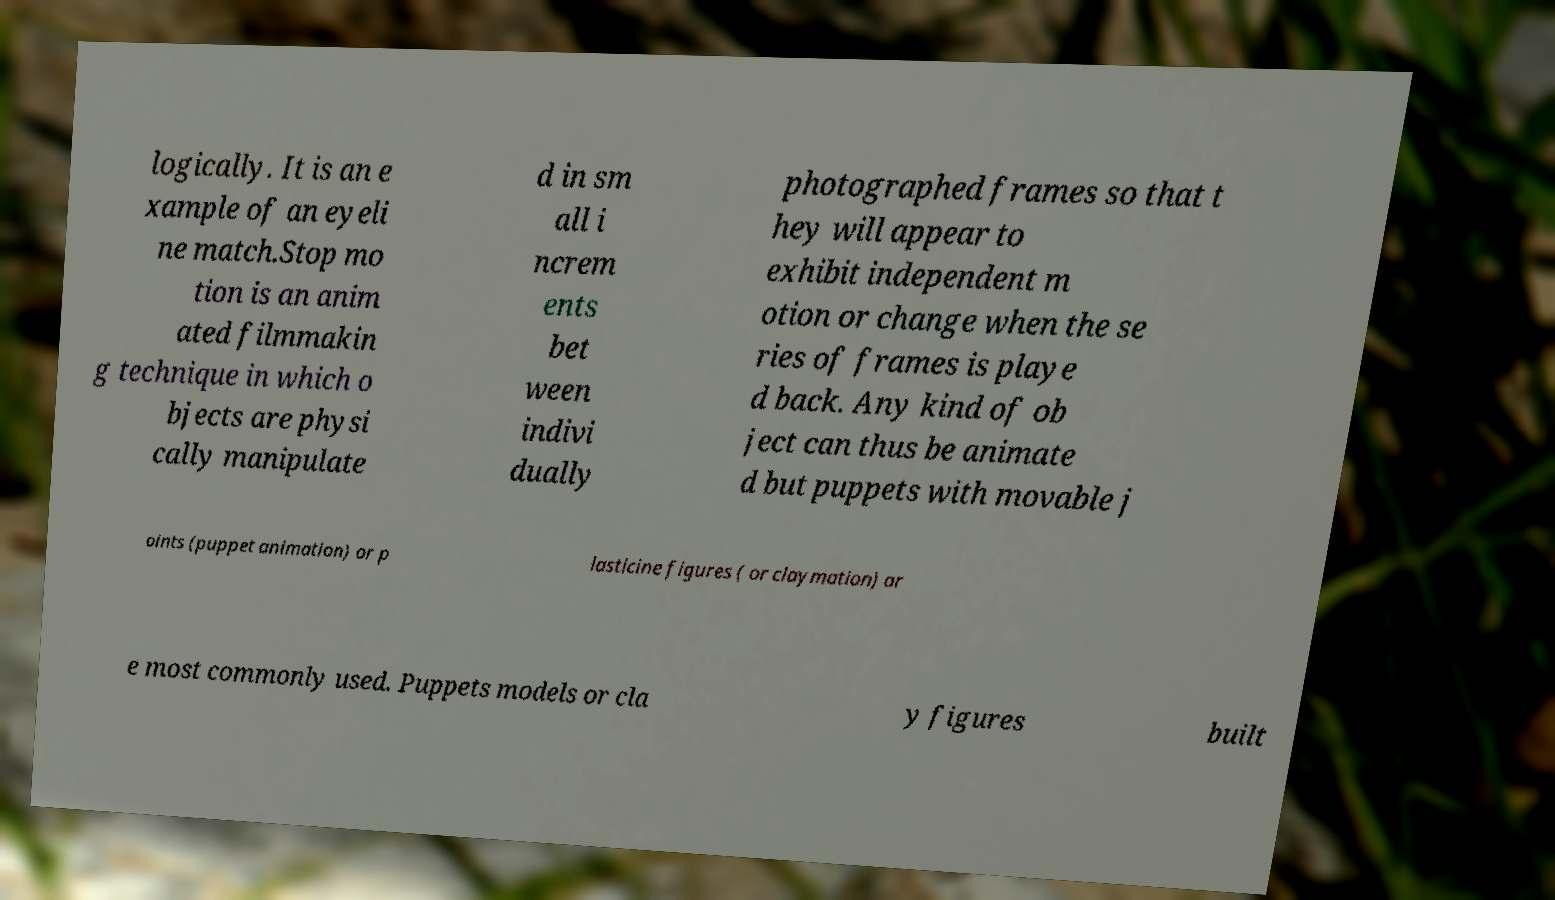What messages or text are displayed in this image? I need them in a readable, typed format. logically. It is an e xample of an eyeli ne match.Stop mo tion is an anim ated filmmakin g technique in which o bjects are physi cally manipulate d in sm all i ncrem ents bet ween indivi dually photographed frames so that t hey will appear to exhibit independent m otion or change when the se ries of frames is playe d back. Any kind of ob ject can thus be animate d but puppets with movable j oints (puppet animation) or p lasticine figures ( or claymation) ar e most commonly used. Puppets models or cla y figures built 